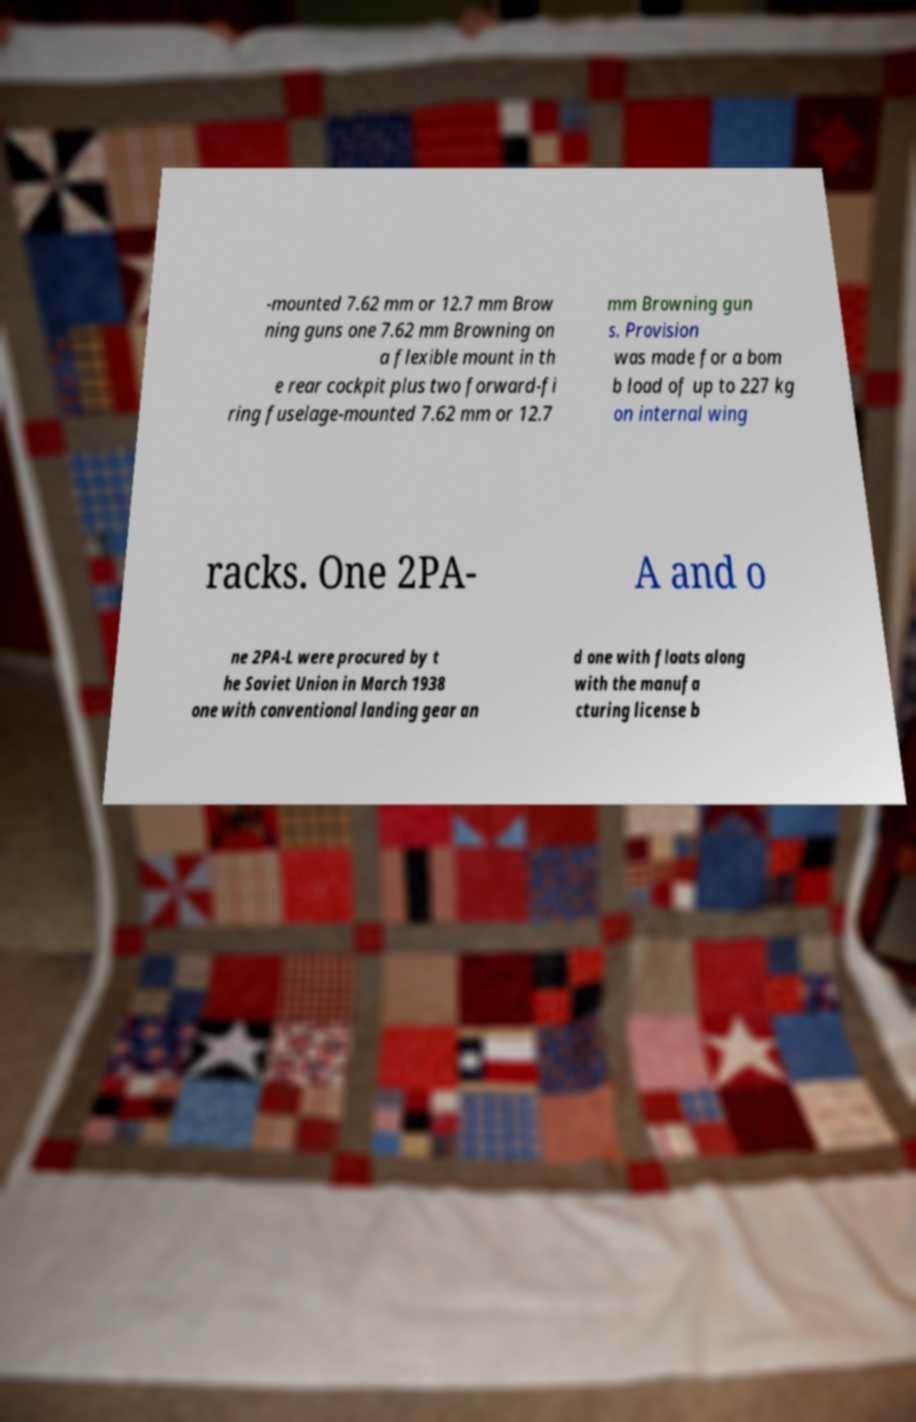I need the written content from this picture converted into text. Can you do that? -mounted 7.62 mm or 12.7 mm Brow ning guns one 7.62 mm Browning on a flexible mount in th e rear cockpit plus two forward-fi ring fuselage-mounted 7.62 mm or 12.7 mm Browning gun s. Provision was made for a bom b load of up to 227 kg on internal wing racks. One 2PA- A and o ne 2PA-L were procured by t he Soviet Union in March 1938 one with conventional landing gear an d one with floats along with the manufa cturing license b 